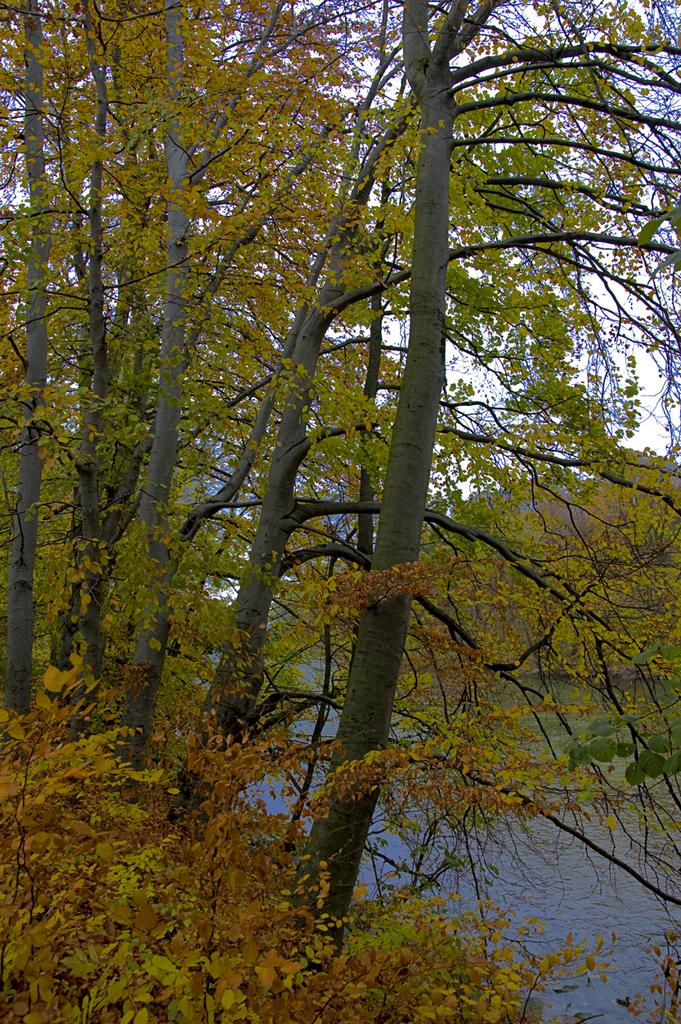What type of vegetation is in the foreground of the image? There are trees in the foreground of the image. What can be seen in the background of the image? Water and the sky are visible in the background of the image. What type of cherry is being used to express anger in the image? There is no cherry or expression of anger present in the image. What type of boot is visible in the image? There is no boot present in the image. 